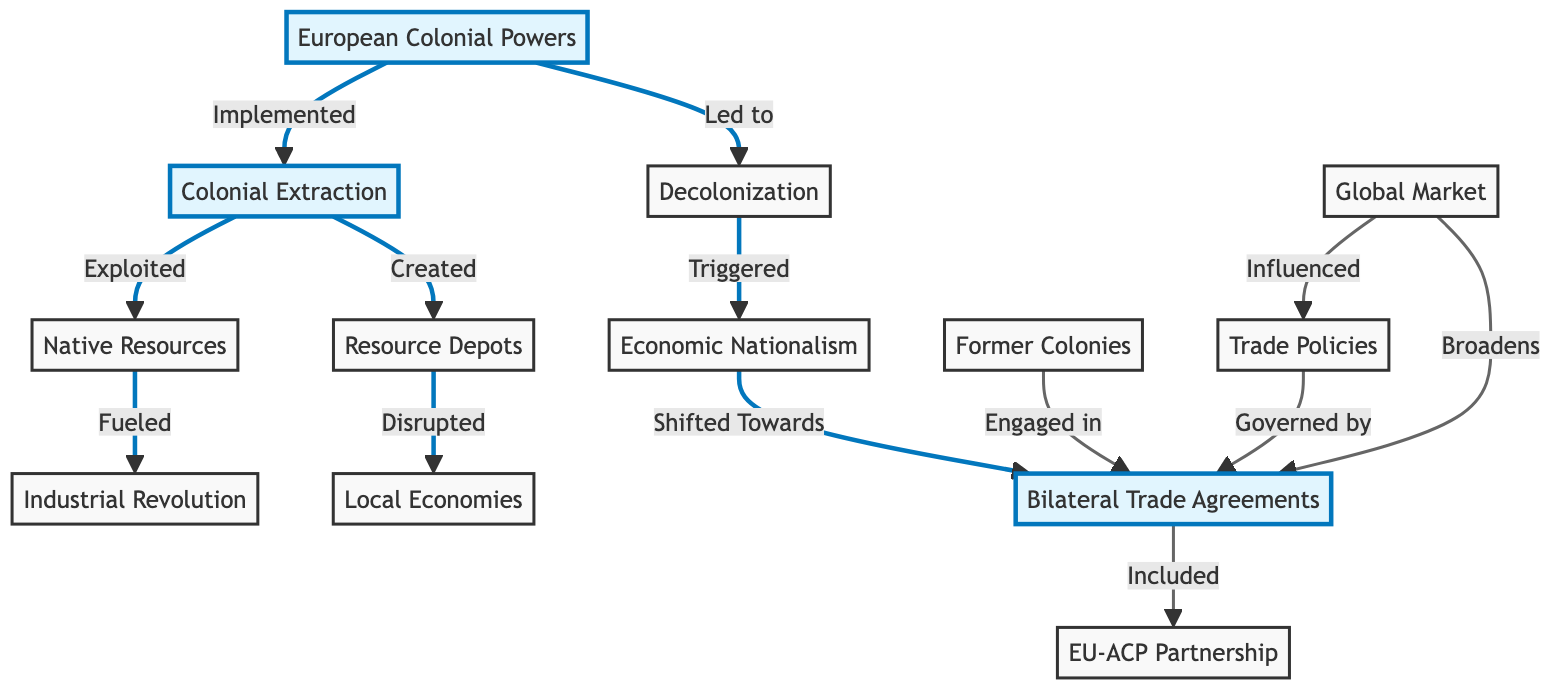What is the starting node of the diagram? The starting node of the diagram is "European Colonial Powers," which is the first node that indicates the initial factor leading to Colonial Extraction.
Answer: European Colonial Powers How many nodes are present in the diagram? To determine the total number of nodes, count the list provided in the data: there are 12 nodes in total.
Answer: 12 What relationship connects "Colonial Extraction" to "Native Resources"? The relationship between these two nodes is "Exploited," as indicated by the directed edge.
Answer: Exploited Which node is directly influenced by "Decolonization"? The node that is directly influenced by "Decolonization" is "Economic Nationalism," as it is triggered after decolonization occurs.
Answer: Economic Nationalism What is the end point of the path starting from "Economic Nationalism"? Following the path from "Economic Nationalism," the end point is "Bilateral Trade Agreements," which it shifts towards after triggering.
Answer: Bilateral Trade Agreements How does "Global Market" affect "Trade Policies"? "Global Market" influences "Trade Policies" by providing external conditions that govern how those trade policies are shaped.
Answer: Influenced Which node signifies the partnership following "Bilateral Trade Agreements"? The node that signifies the partnership following "Bilateral Trade Agreements" is "EU-ACP Partnership Agreement," as it is included in the broader context of bilateral trade.
Answer: EU-ACP Partnership Agreement What happens between "Resource Depots" and "Local Economies"? The relationship states that "Resource Depots" disrupt "Local Economies," indicating the negative impact due to colonial exploitation.
Answer: Disrupted What is the final effect of "Global Market" on "Bilateral Trade Agreements"? The effect of "Global Market" on "Bilateral Trade Agreements" is that it broadens them, indicating an expansion of trading options and opportunities.
Answer: Broadens 